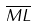<formula> <loc_0><loc_0><loc_500><loc_500>\overline { M L }</formula> 